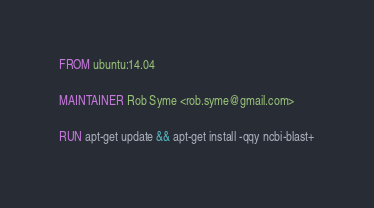Convert code to text. <code><loc_0><loc_0><loc_500><loc_500><_Dockerfile_>FROM ubuntu:14.04

MAINTAINER Rob Syme <rob.syme@gmail.com>

RUN apt-get update && apt-get install -qqy ncbi-blast+
</code> 